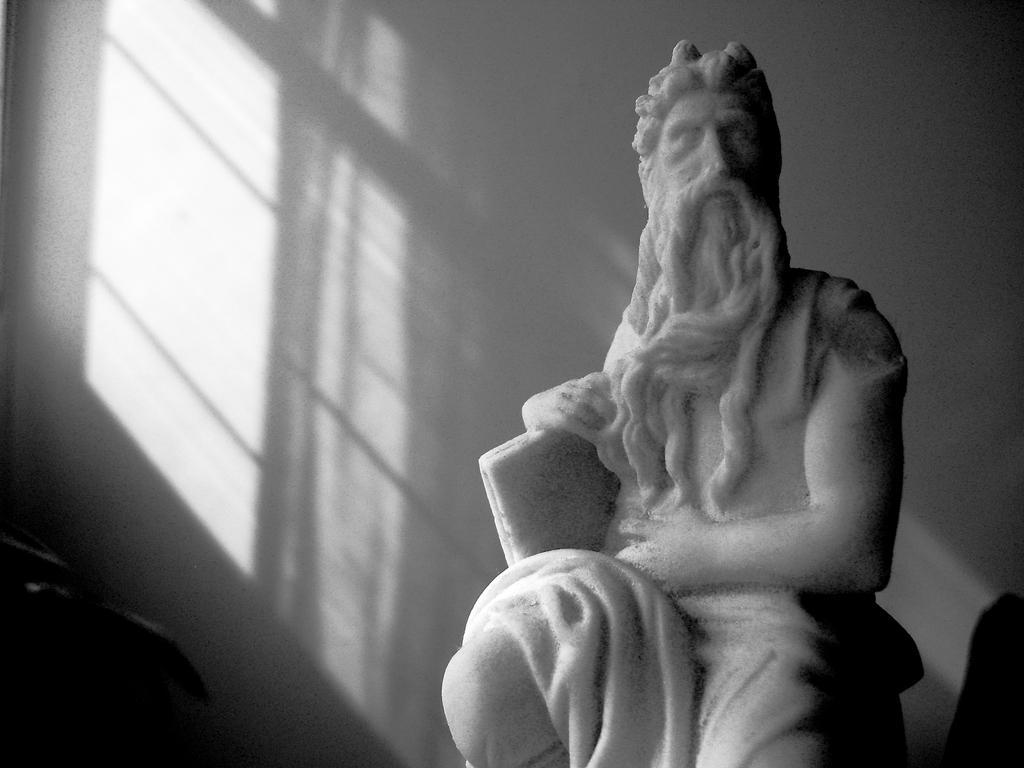How would you summarize this image in a sentence or two? In the picture I can see sculpture of a person and in the background there is a wall. 